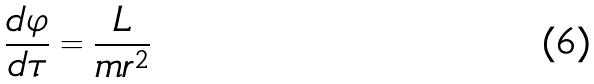<formula> <loc_0><loc_0><loc_500><loc_500>\frac { d \varphi } { d \tau } = \frac { L } { m r ^ { 2 } }</formula> 